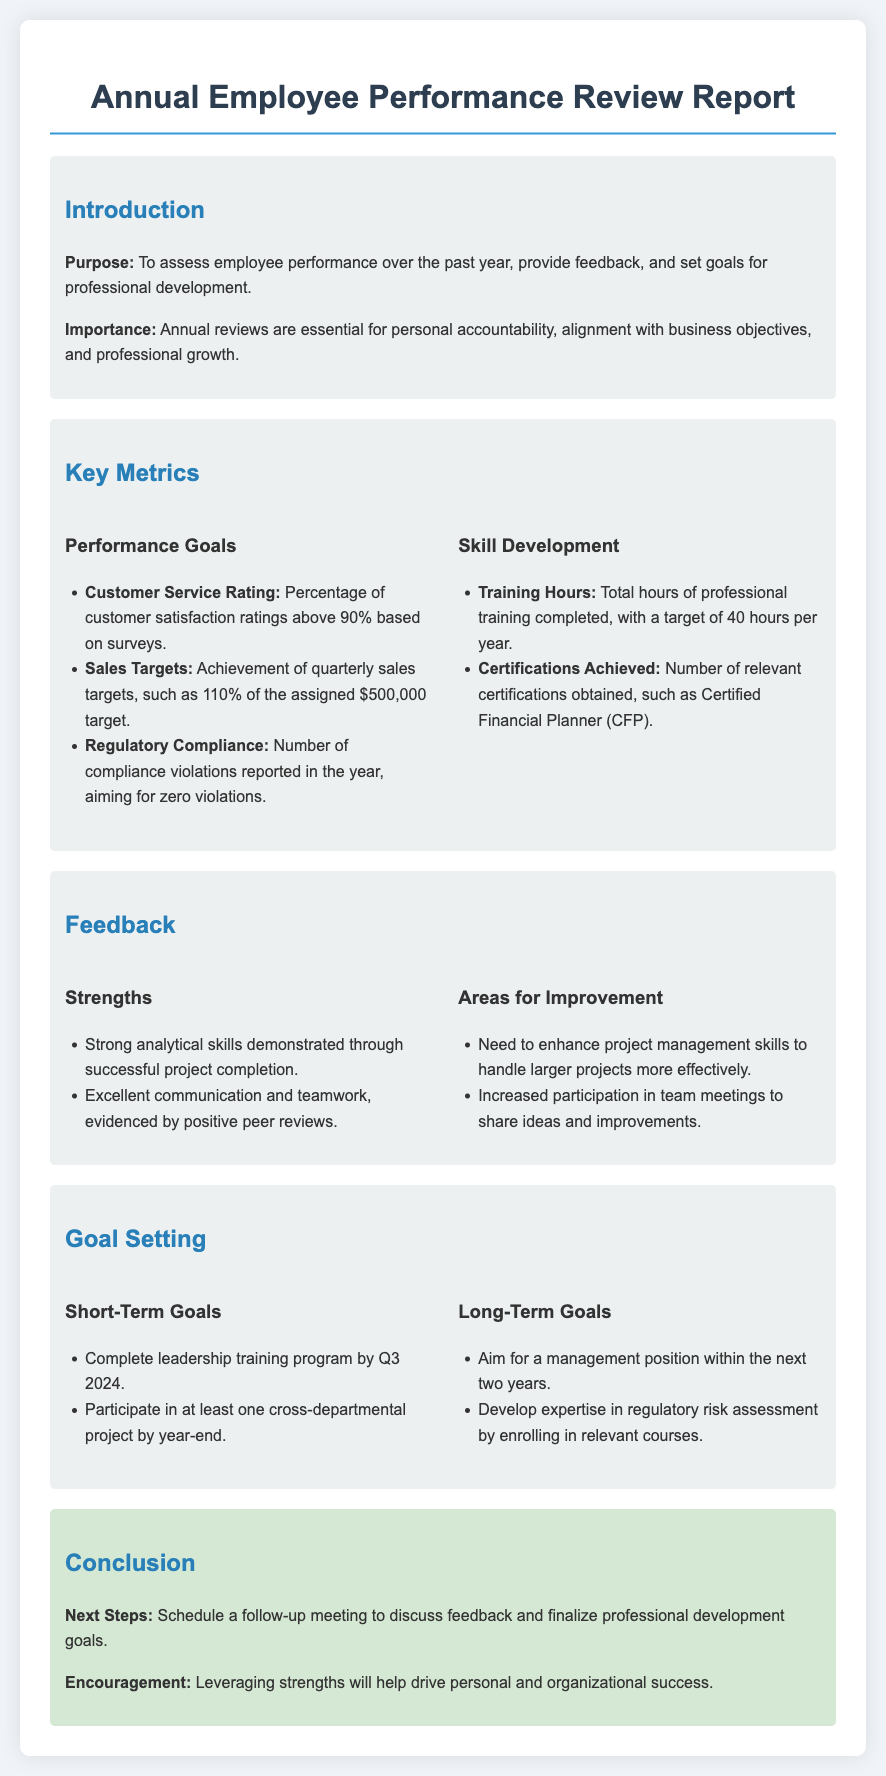What is the purpose of the document? The purpose of the document is to assess employee performance over the past year, provide feedback, and set goals for professional development.
Answer: To assess employee performance over the past year, provide feedback, and set goals for professional development What is the target for customer service rating? The target for customer service rating is the percentage of customer satisfaction ratings above 90% based on surveys.
Answer: Above 90% How many training hours are targeted per year? The total hours of professional training completed, with a target of 40 hours per year.
Answer: 40 hours What are the two strengths listed in the feedback section? The strengths mentioned include strong analytical skills demonstrated through successful project completion, and excellent communication and teamwork, evidenced by positive peer reviews.
Answer: Strong analytical skills, excellent communication and teamwork What is one area for improvement? One area for improvement mentioned is the need to enhance project management skills to handle larger projects more effectively.
Answer: Enhance project management skills What is a short-term goal mentioned in the goal-setting section? One short-term goal is to complete the leadership training program by Q3 2024.
Answer: Complete leadership training program by Q3 2024 What does the conclusion suggest as a next step? The conclusion suggests scheduling a follow-up meeting to discuss feedback and finalize professional development goals.
Answer: Schedule a follow-up meeting What is one long-term goal listed in the document? One long-term goal is to aim for a management position within the next two years.
Answer: Aim for a management position within the next two years 